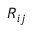<formula> <loc_0><loc_0><loc_500><loc_500>R _ { i j }</formula> 